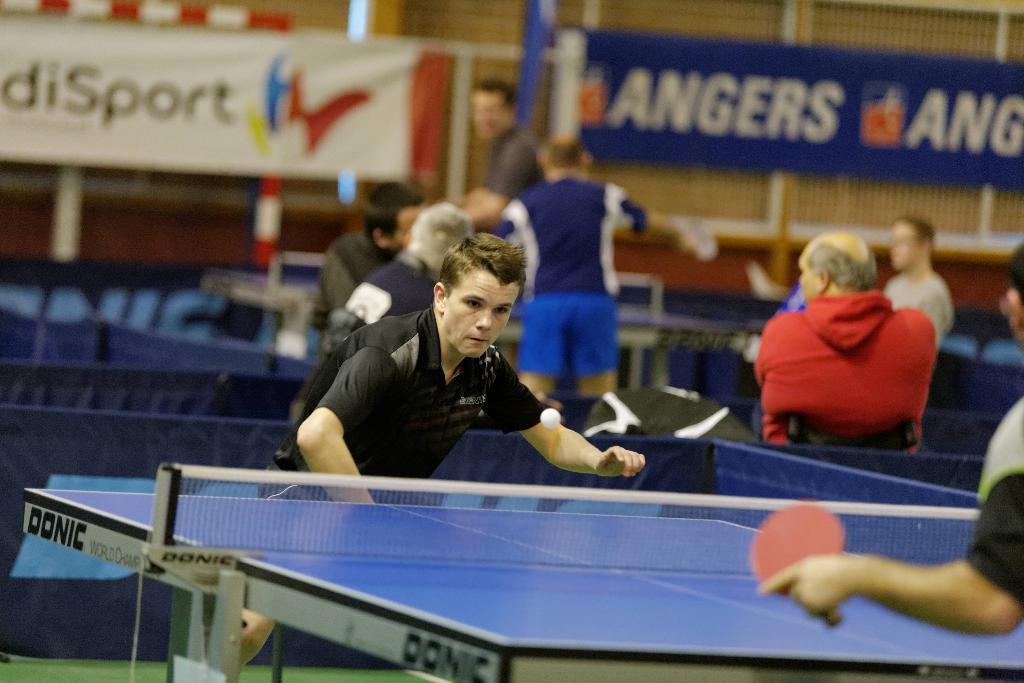Please provide a concise description of this image. It is a sports room, a person who is wearing black shirt in the front is playing table tennis ,there are also some other people behind him some of them are sitting and some of them are standing ,in the background there are two different banners. 